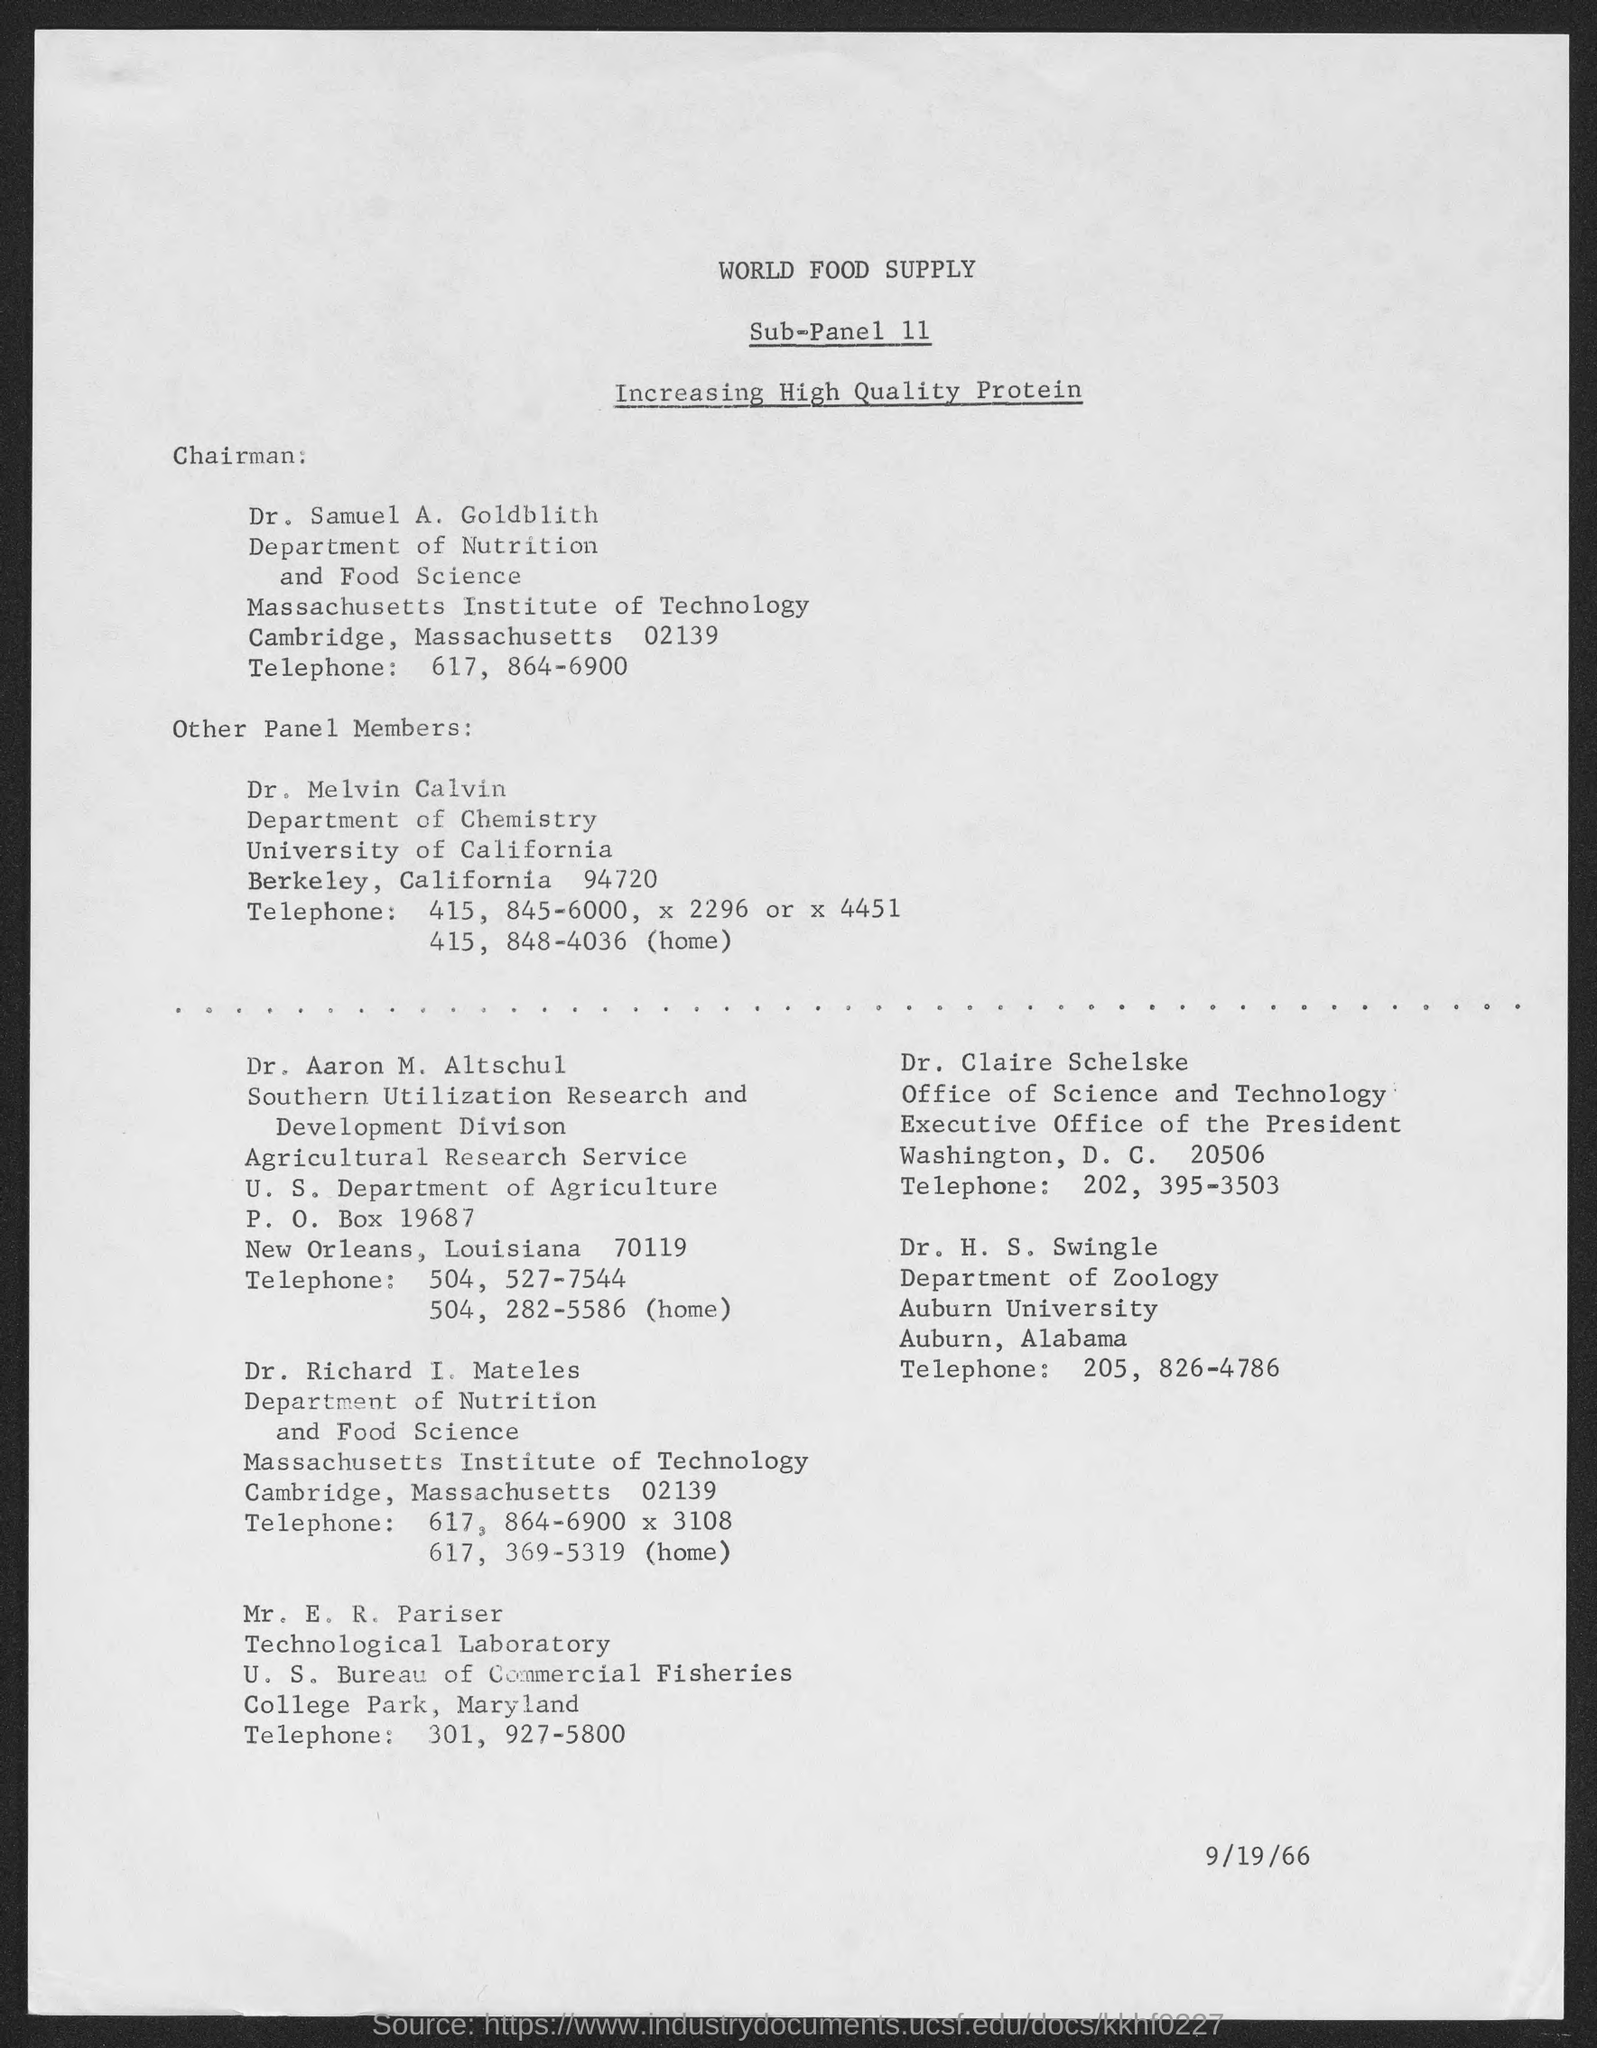Highlight a few significant elements in this photo. The document was dated on September 19, 1966. Dr. H.S. Swingle is a member of the Department of Zoology. The title of Sub-panel 11 is 'Increasing High-Quality Protein', which focuses on improving the production and availability of high-quality protein sources for animal agriculture. The Chairman is Dr. Samuel A. Goldblith. Dr. Samuel's telephone number is 617-864-6900. 